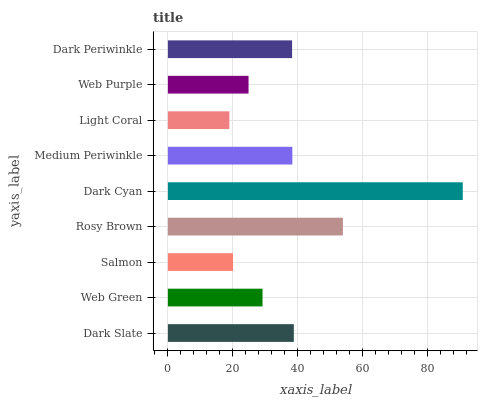Is Light Coral the minimum?
Answer yes or no. Yes. Is Dark Cyan the maximum?
Answer yes or no. Yes. Is Web Green the minimum?
Answer yes or no. No. Is Web Green the maximum?
Answer yes or no. No. Is Dark Slate greater than Web Green?
Answer yes or no. Yes. Is Web Green less than Dark Slate?
Answer yes or no. Yes. Is Web Green greater than Dark Slate?
Answer yes or no. No. Is Dark Slate less than Web Green?
Answer yes or no. No. Is Dark Periwinkle the high median?
Answer yes or no. Yes. Is Dark Periwinkle the low median?
Answer yes or no. Yes. Is Dark Slate the high median?
Answer yes or no. No. Is Web Purple the low median?
Answer yes or no. No. 